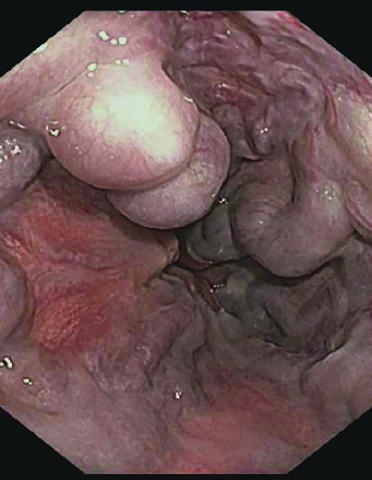s the cut surface striking?
Answer the question using a single word or phrase. No 